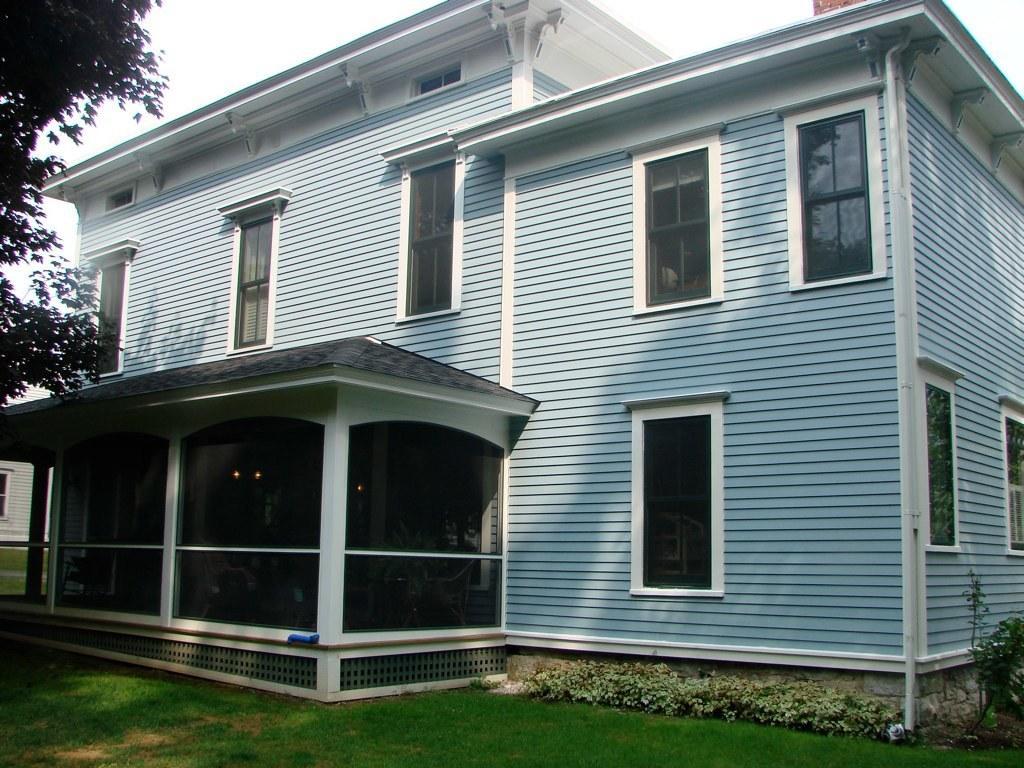Please provide a concise description of this image. In this image I can see the house, few glass windows, trees and the sky is in white color. 